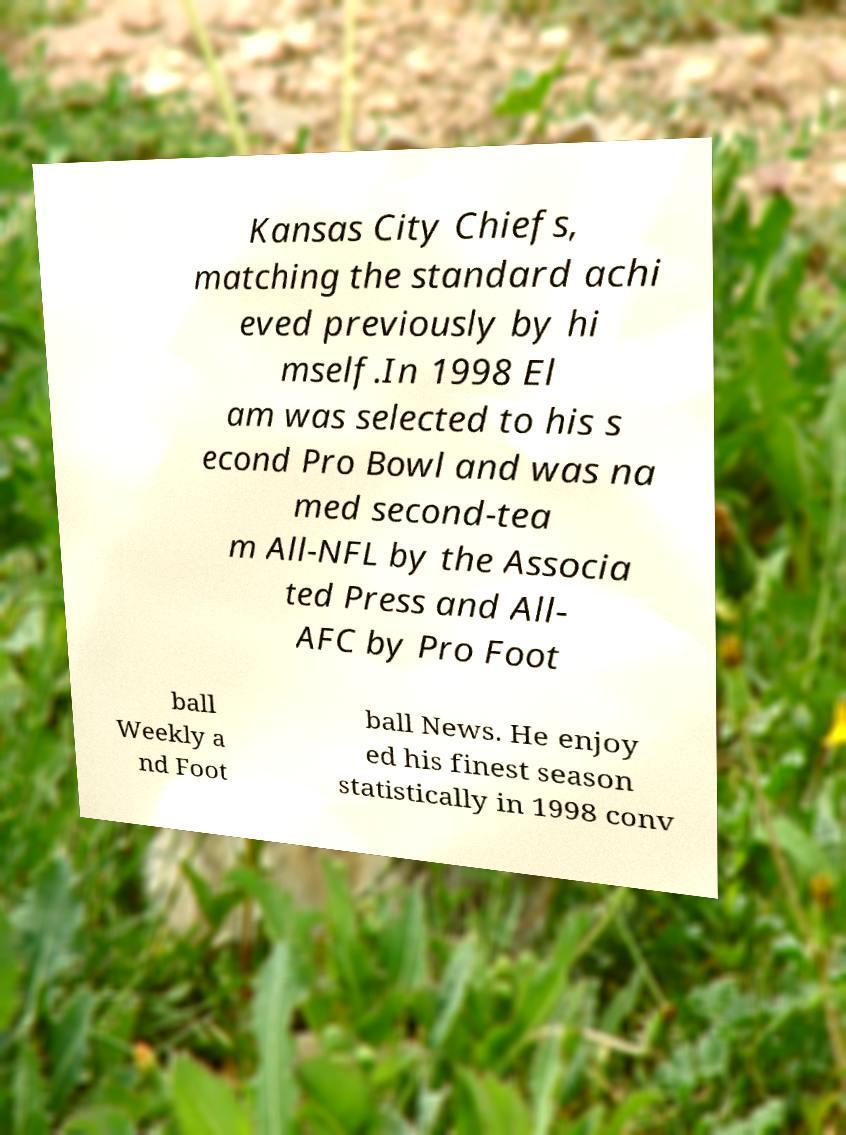There's text embedded in this image that I need extracted. Can you transcribe it verbatim? Kansas City Chiefs, matching the standard achi eved previously by hi mself.In 1998 El am was selected to his s econd Pro Bowl and was na med second-tea m All-NFL by the Associa ted Press and All- AFC by Pro Foot ball Weekly a nd Foot ball News. He enjoy ed his finest season statistically in 1998 conv 